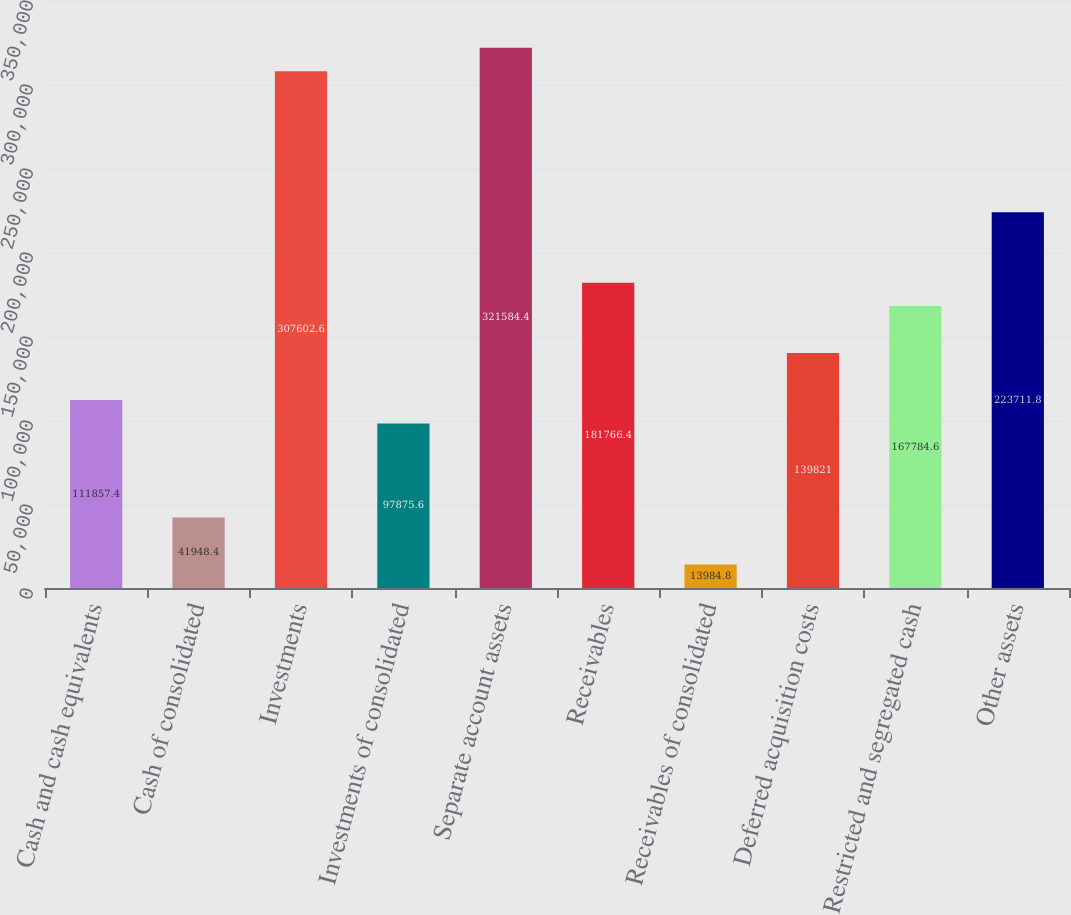Convert chart. <chart><loc_0><loc_0><loc_500><loc_500><bar_chart><fcel>Cash and cash equivalents<fcel>Cash of consolidated<fcel>Investments<fcel>Investments of consolidated<fcel>Separate account assets<fcel>Receivables<fcel>Receivables of consolidated<fcel>Deferred acquisition costs<fcel>Restricted and segregated cash<fcel>Other assets<nl><fcel>111857<fcel>41948.4<fcel>307603<fcel>97875.6<fcel>321584<fcel>181766<fcel>13984.8<fcel>139821<fcel>167785<fcel>223712<nl></chart> 